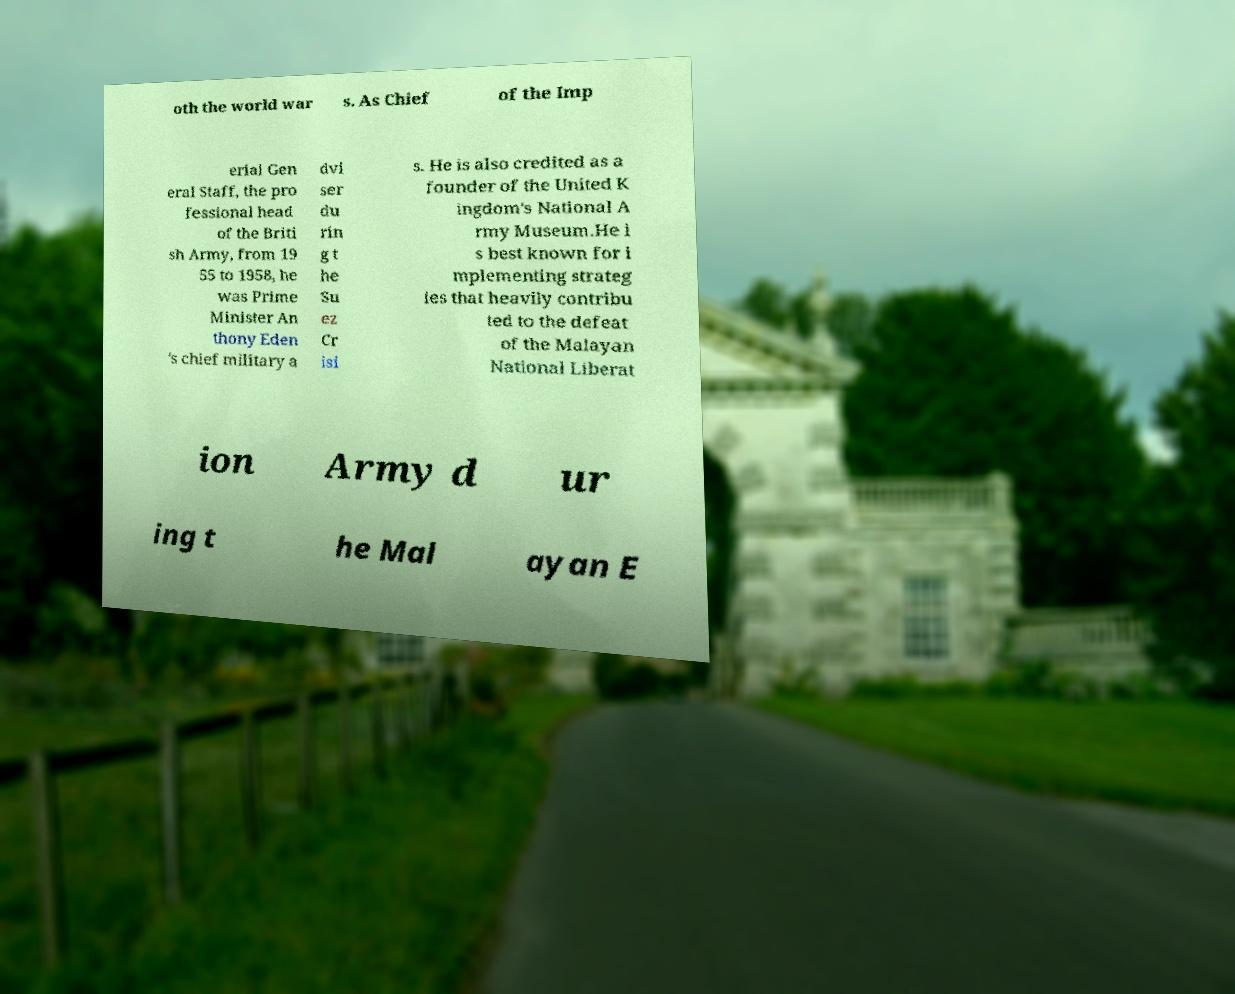Could you assist in decoding the text presented in this image and type it out clearly? oth the world war s. As Chief of the Imp erial Gen eral Staff, the pro fessional head of the Briti sh Army, from 19 55 to 1958, he was Prime Minister An thony Eden 's chief military a dvi ser du rin g t he Su ez Cr isi s. He is also credited as a founder of the United K ingdom's National A rmy Museum.He i s best known for i mplementing strateg ies that heavily contribu ted to the defeat of the Malayan National Liberat ion Army d ur ing t he Mal ayan E 